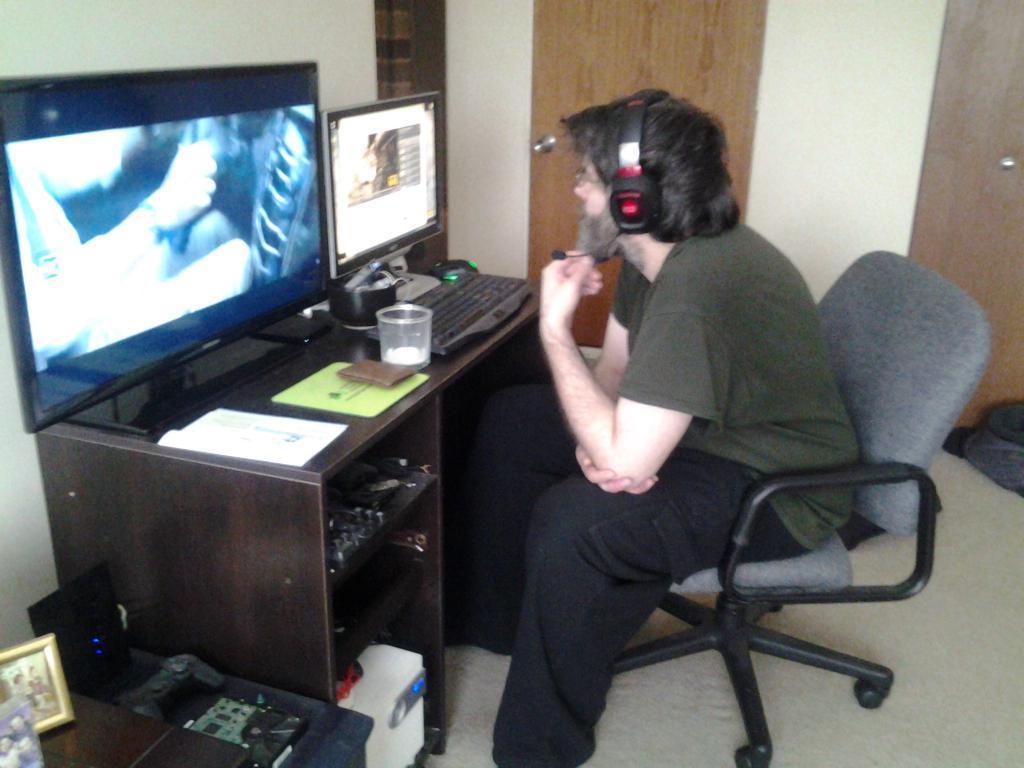How would you summarize this image in a sentence or two? In this aimeg, we can see a person is sitting on a chair and wearing headphones. Here we can see desk, few things and objects. On the desk, we can see television, monitor, keyboard and a few things. Background we can see wall, door, and some objects. At the bottom, there is a floor. 